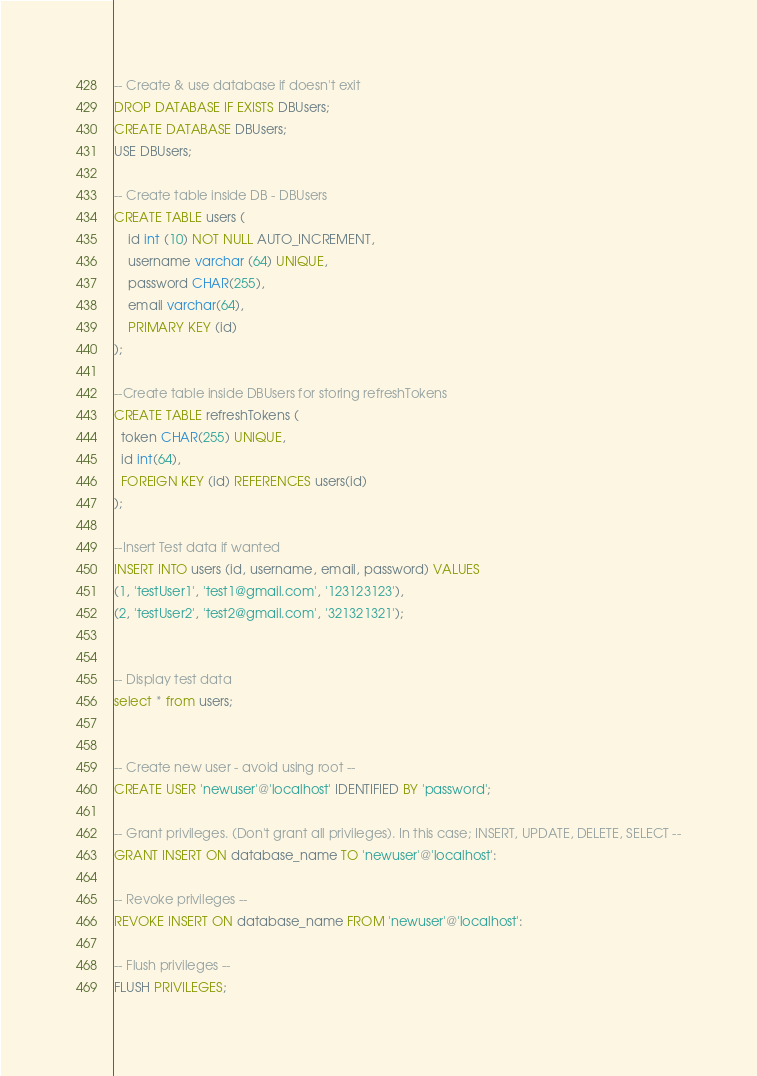<code> <loc_0><loc_0><loc_500><loc_500><_SQL_>
-- Create & use database if doesn't exit
DROP DATABASE IF EXISTS DBUsers;
CREATE DATABASE DBUsers; 
USE DBUsers;

-- Create table inside DB - DBUsers
CREATE TABLE users (
    id int (10) NOT NULL AUTO_INCREMENT, 
    username varchar (64) UNIQUE, 
    password CHAR(255),
    email varchar(64),
    PRIMARY KEY (id)
);

--Create table inside DBUsers for storing refreshTokens
CREATE TABLE refreshTokens ( 
  token CHAR(255) UNIQUE,
  id int(64),
  FOREIGN KEY (id) REFERENCES users(id)
);

--Insert Test data if wanted
INSERT INTO users (id, username, email, password) VALUES
(1, 'testUser1', 'test1@gmail.com', '123123123'),
(2, 'testUser2', 'test2@gmail.com', '321321321');


-- Display test data
select * from users;


-- Create new user - avoid using root -- 
CREATE USER 'newuser'@'localhost' IDENTIFIED BY 'password';

-- Grant privileges. (Don't grant all privileges). In this case; INSERT, UPDATE, DELETE, SELECT --
GRANT INSERT ON database_name TO 'newuser'@'localhost':

-- Revoke privileges --
REVOKE INSERT ON database_name FROM 'newuser'@'localhost':

-- Flush privileges -- 
FLUSH PRIVILEGES; 


</code> 